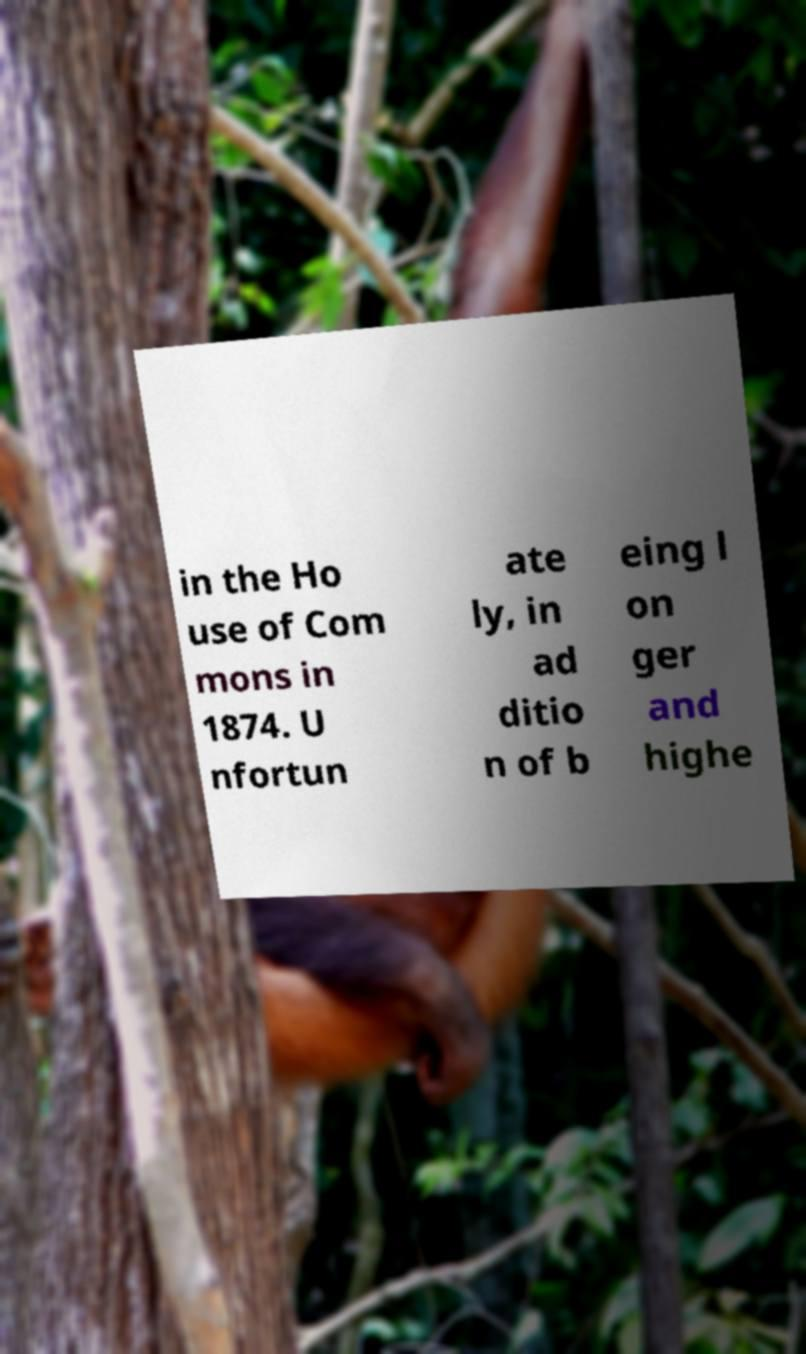Can you read and provide the text displayed in the image?This photo seems to have some interesting text. Can you extract and type it out for me? in the Ho use of Com mons in 1874. U nfortun ate ly, in ad ditio n of b eing l on ger and highe 